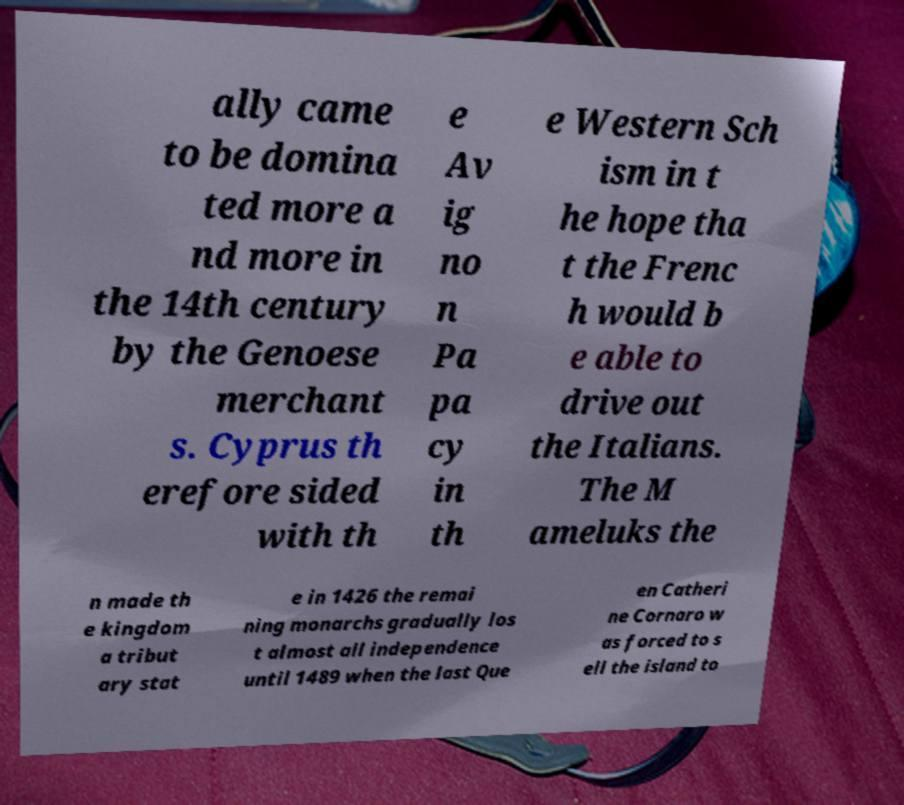Can you read and provide the text displayed in the image?This photo seems to have some interesting text. Can you extract and type it out for me? ally came to be domina ted more a nd more in the 14th century by the Genoese merchant s. Cyprus th erefore sided with th e Av ig no n Pa pa cy in th e Western Sch ism in t he hope tha t the Frenc h would b e able to drive out the Italians. The M ameluks the n made th e kingdom a tribut ary stat e in 1426 the remai ning monarchs gradually los t almost all independence until 1489 when the last Que en Catheri ne Cornaro w as forced to s ell the island to 